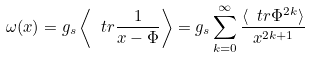Convert formula to latex. <formula><loc_0><loc_0><loc_500><loc_500>\omega ( x ) = g _ { s } \left \langle \ t r \frac { 1 } { x - \Phi } \right \rangle = g _ { s } \sum _ { k = 0 } ^ { \infty } \frac { \langle \ t r \Phi ^ { 2 k } \rangle } { x ^ { 2 k + 1 } }</formula> 